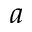Convert formula to latex. <formula><loc_0><loc_0><loc_500><loc_500>a</formula> 